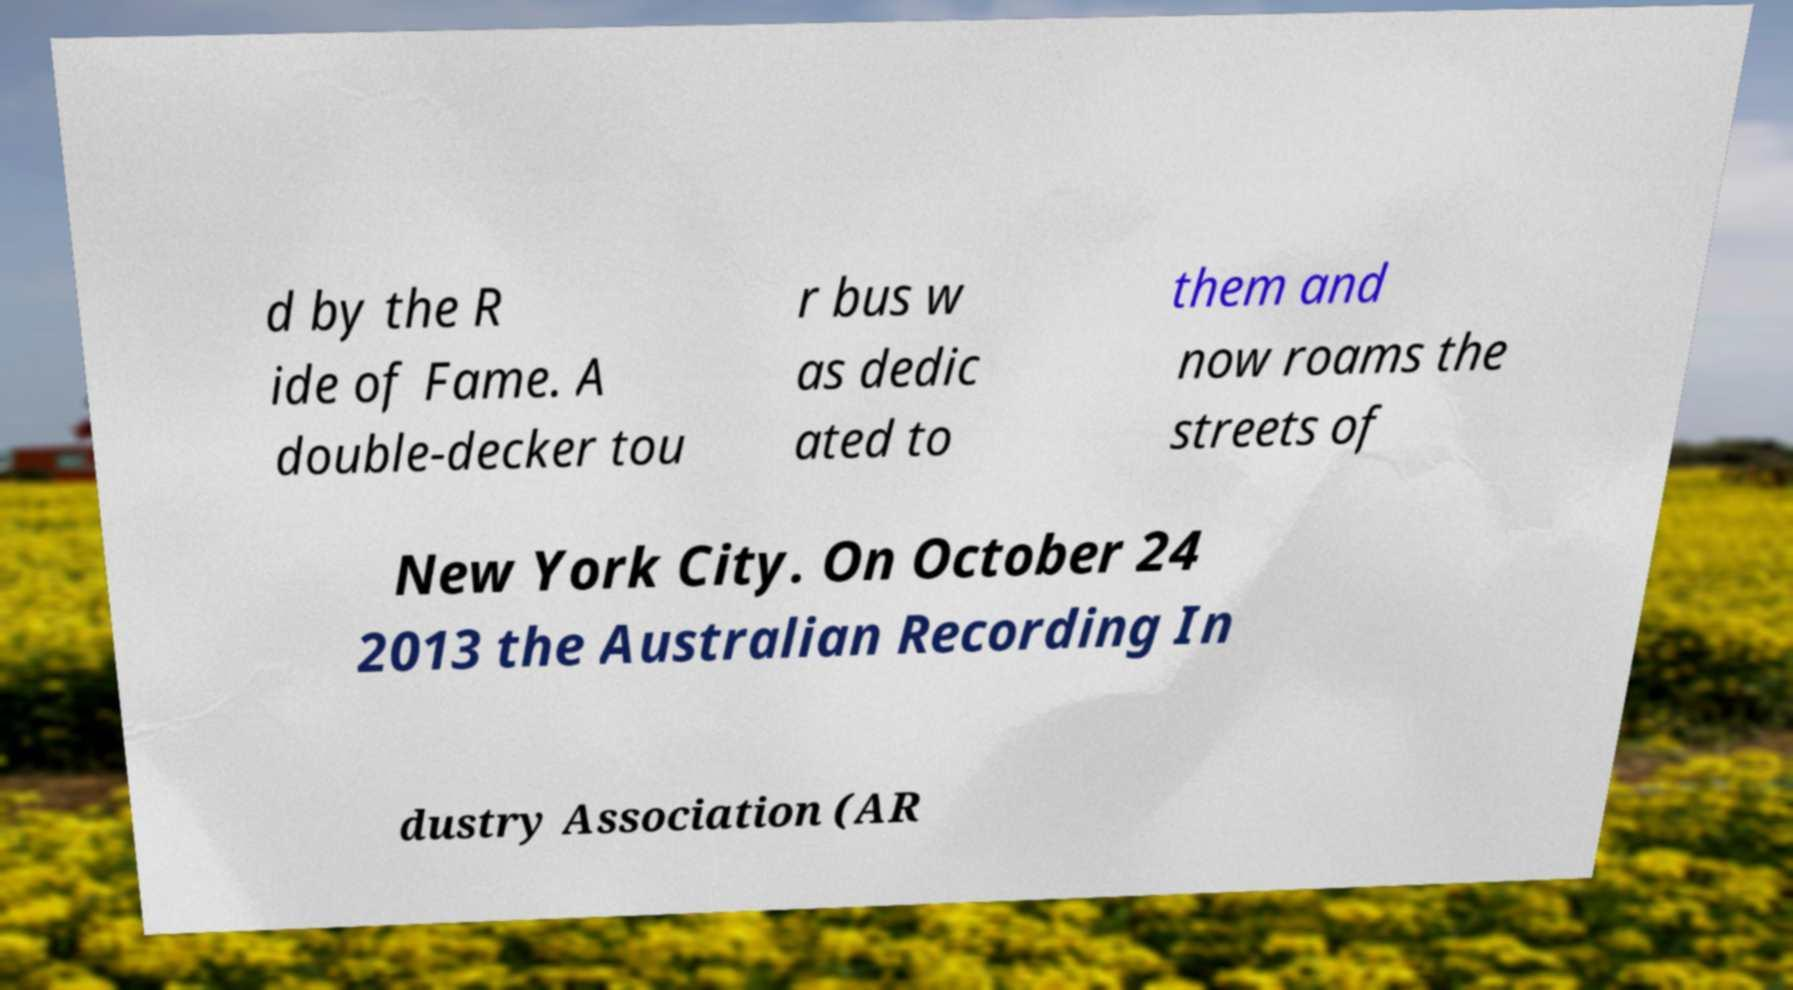Can you read and provide the text displayed in the image?This photo seems to have some interesting text. Can you extract and type it out for me? d by the R ide of Fame. A double-decker tou r bus w as dedic ated to them and now roams the streets of New York City. On October 24 2013 the Australian Recording In dustry Association (AR 